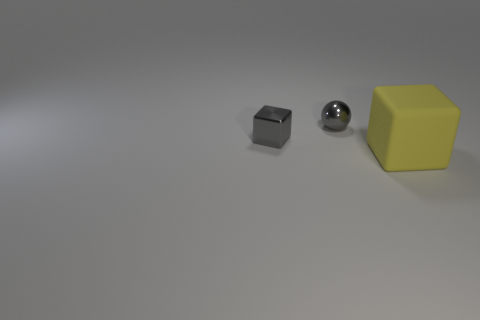Is the yellow cube larger than the gray cube in the image? No, the yellow cube is not larger; it is in fact the same size as the gray cube but appears bigger due to its brighter color and closer position to the perspective of the camera. 